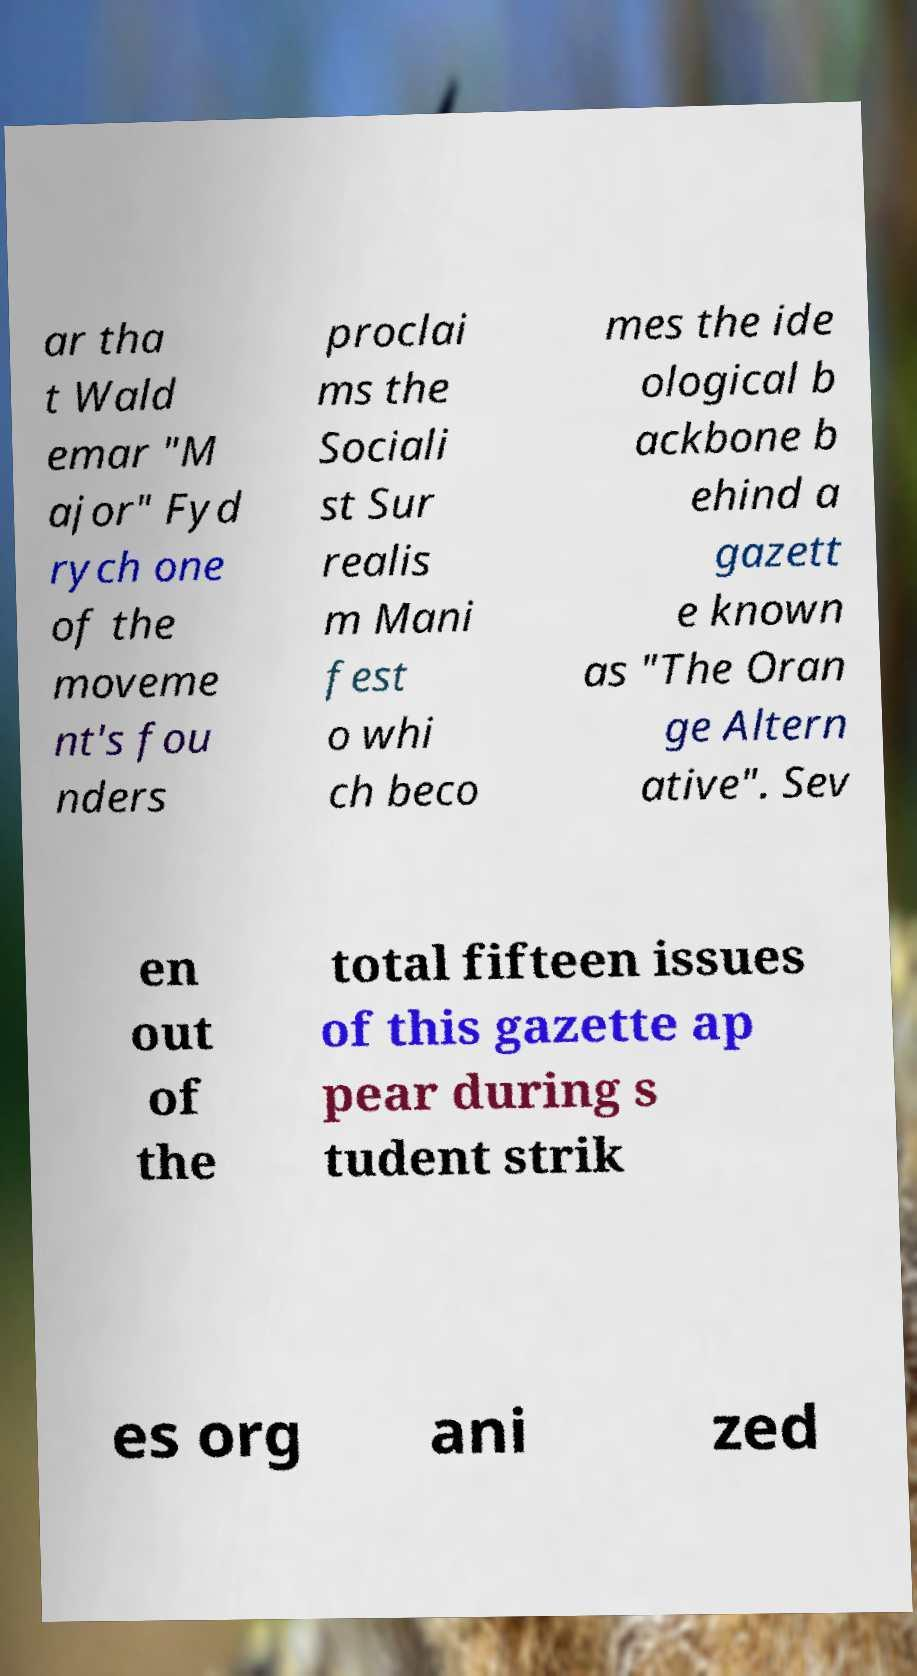There's text embedded in this image that I need extracted. Can you transcribe it verbatim? ar tha t Wald emar "M ajor" Fyd rych one of the moveme nt's fou nders proclai ms the Sociali st Sur realis m Mani fest o whi ch beco mes the ide ological b ackbone b ehind a gazett e known as "The Oran ge Altern ative". Sev en out of the total fifteen issues of this gazette ap pear during s tudent strik es org ani zed 